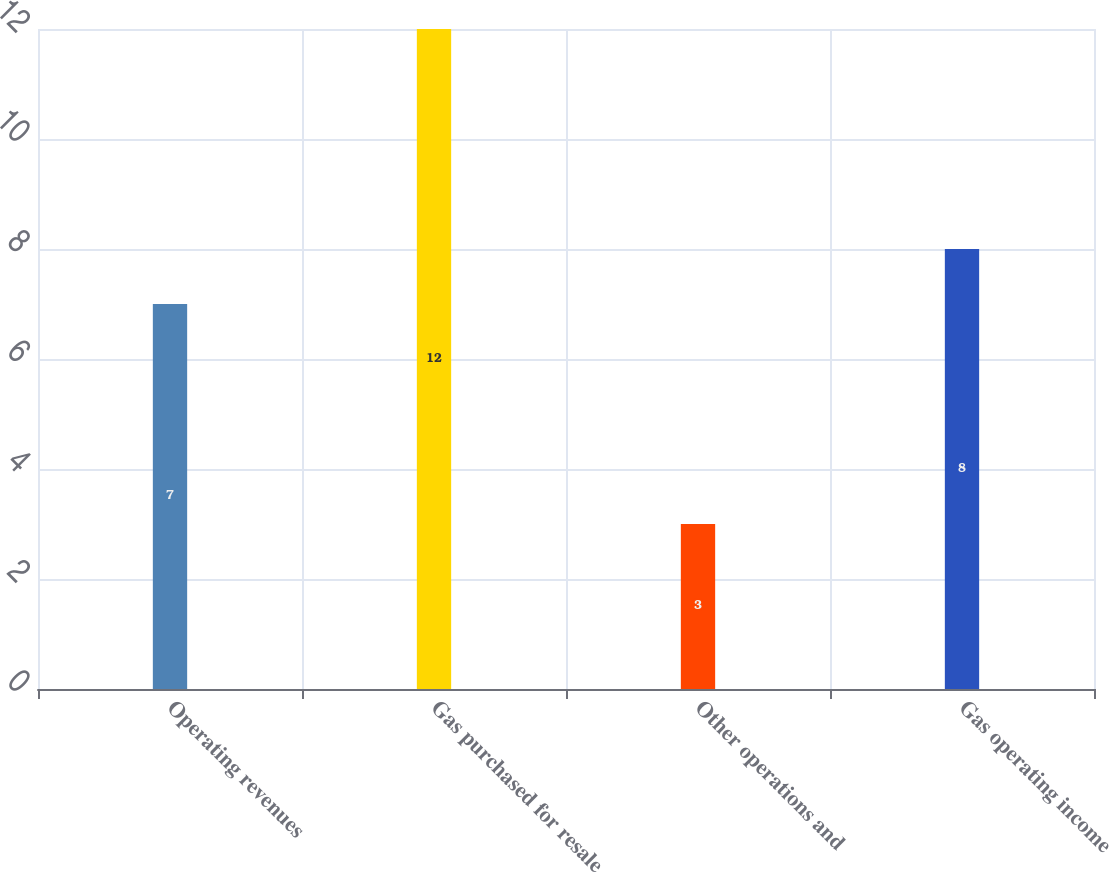<chart> <loc_0><loc_0><loc_500><loc_500><bar_chart><fcel>Operating revenues<fcel>Gas purchased for resale<fcel>Other operations and<fcel>Gas operating income<nl><fcel>7<fcel>12<fcel>3<fcel>8<nl></chart> 